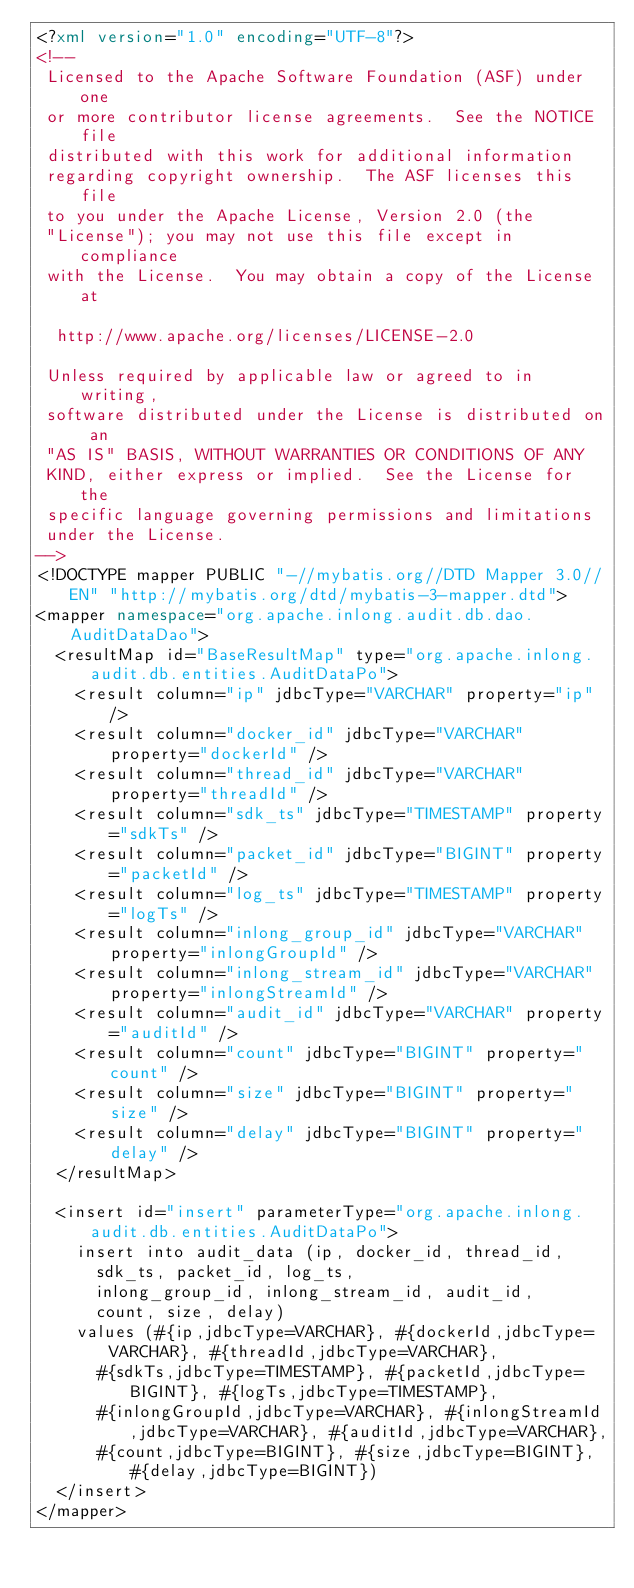Convert code to text. <code><loc_0><loc_0><loc_500><loc_500><_XML_><?xml version="1.0" encoding="UTF-8"?>
<!--
 Licensed to the Apache Software Foundation (ASF) under one
 or more contributor license agreements.  See the NOTICE file
 distributed with this work for additional information
 regarding copyright ownership.  The ASF licenses this file
 to you under the Apache License, Version 2.0 (the
 "License"); you may not use this file except in compliance
 with the License.  You may obtain a copy of the License at

  http://www.apache.org/licenses/LICENSE-2.0

 Unless required by applicable law or agreed to in writing,
 software distributed under the License is distributed on an
 "AS IS" BASIS, WITHOUT WARRANTIES OR CONDITIONS OF ANY
 KIND, either express or implied.  See the License for the
 specific language governing permissions and limitations
 under the License.
-->
<!DOCTYPE mapper PUBLIC "-//mybatis.org//DTD Mapper 3.0//EN" "http://mybatis.org/dtd/mybatis-3-mapper.dtd">
<mapper namespace="org.apache.inlong.audit.db.dao.AuditDataDao">
  <resultMap id="BaseResultMap" type="org.apache.inlong.audit.db.entities.AuditDataPo">
    <result column="ip" jdbcType="VARCHAR" property="ip" />
    <result column="docker_id" jdbcType="VARCHAR" property="dockerId" />
    <result column="thread_id" jdbcType="VARCHAR" property="threadId" />
    <result column="sdk_ts" jdbcType="TIMESTAMP" property="sdkTs" />
    <result column="packet_id" jdbcType="BIGINT" property="packetId" />
    <result column="log_ts" jdbcType="TIMESTAMP" property="logTs" />
    <result column="inlong_group_id" jdbcType="VARCHAR" property="inlongGroupId" />
    <result column="inlong_stream_id" jdbcType="VARCHAR" property="inlongStreamId" />
    <result column="audit_id" jdbcType="VARCHAR" property="auditId" />
    <result column="count" jdbcType="BIGINT" property="count" />
    <result column="size" jdbcType="BIGINT" property="size" />
    <result column="delay" jdbcType="BIGINT" property="delay" />
  </resultMap>

  <insert id="insert" parameterType="org.apache.inlong.audit.db.entities.AuditDataPo">
    insert into audit_data (ip, docker_id, thread_id,
      sdk_ts, packet_id, log_ts,
      inlong_group_id, inlong_stream_id, audit_id,
      count, size, delay)
    values (#{ip,jdbcType=VARCHAR}, #{dockerId,jdbcType=VARCHAR}, #{threadId,jdbcType=VARCHAR},
      #{sdkTs,jdbcType=TIMESTAMP}, #{packetId,jdbcType=BIGINT}, #{logTs,jdbcType=TIMESTAMP},
      #{inlongGroupId,jdbcType=VARCHAR}, #{inlongStreamId,jdbcType=VARCHAR}, #{auditId,jdbcType=VARCHAR},
      #{count,jdbcType=BIGINT}, #{size,jdbcType=BIGINT}, #{delay,jdbcType=BIGINT})
  </insert>
</mapper>
</code> 